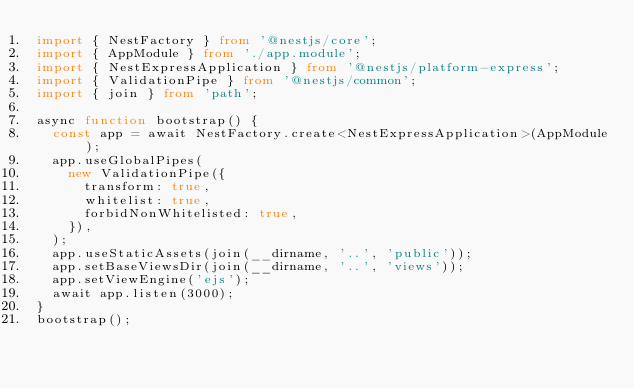<code> <loc_0><loc_0><loc_500><loc_500><_TypeScript_>import { NestFactory } from '@nestjs/core';
import { AppModule } from './app.module';
import { NestExpressApplication } from '@nestjs/platform-express';
import { ValidationPipe } from '@nestjs/common';
import { join } from 'path';

async function bootstrap() {
  const app = await NestFactory.create<NestExpressApplication>(AppModule);
  app.useGlobalPipes(
    new ValidationPipe({
      transform: true,
      whitelist: true,
      forbidNonWhitelisted: true,
    }),
  );
  app.useStaticAssets(join(__dirname, '..', 'public'));
  app.setBaseViewsDir(join(__dirname, '..', 'views'));
  app.setViewEngine('ejs');
  await app.listen(3000);
}
bootstrap();
</code> 